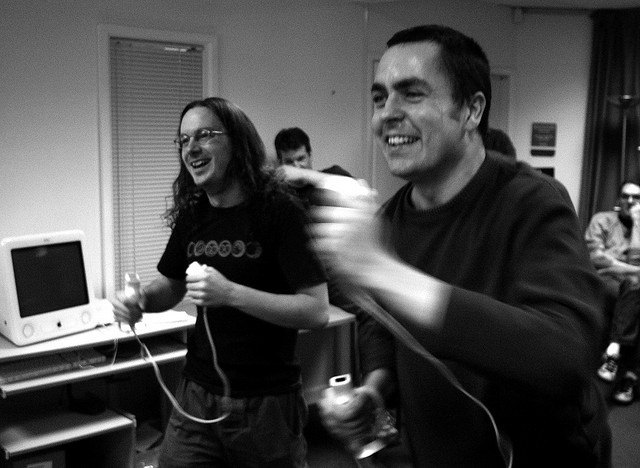Describe the objects in this image and their specific colors. I can see people in gray, black, darkgray, and lightgray tones, people in gray, black, darkgray, and lightgray tones, tv in gray, black, lightgray, and darkgray tones, people in gray, black, darkgray, and lightgray tones, and people in gray, darkgray, black, and lightgray tones in this image. 